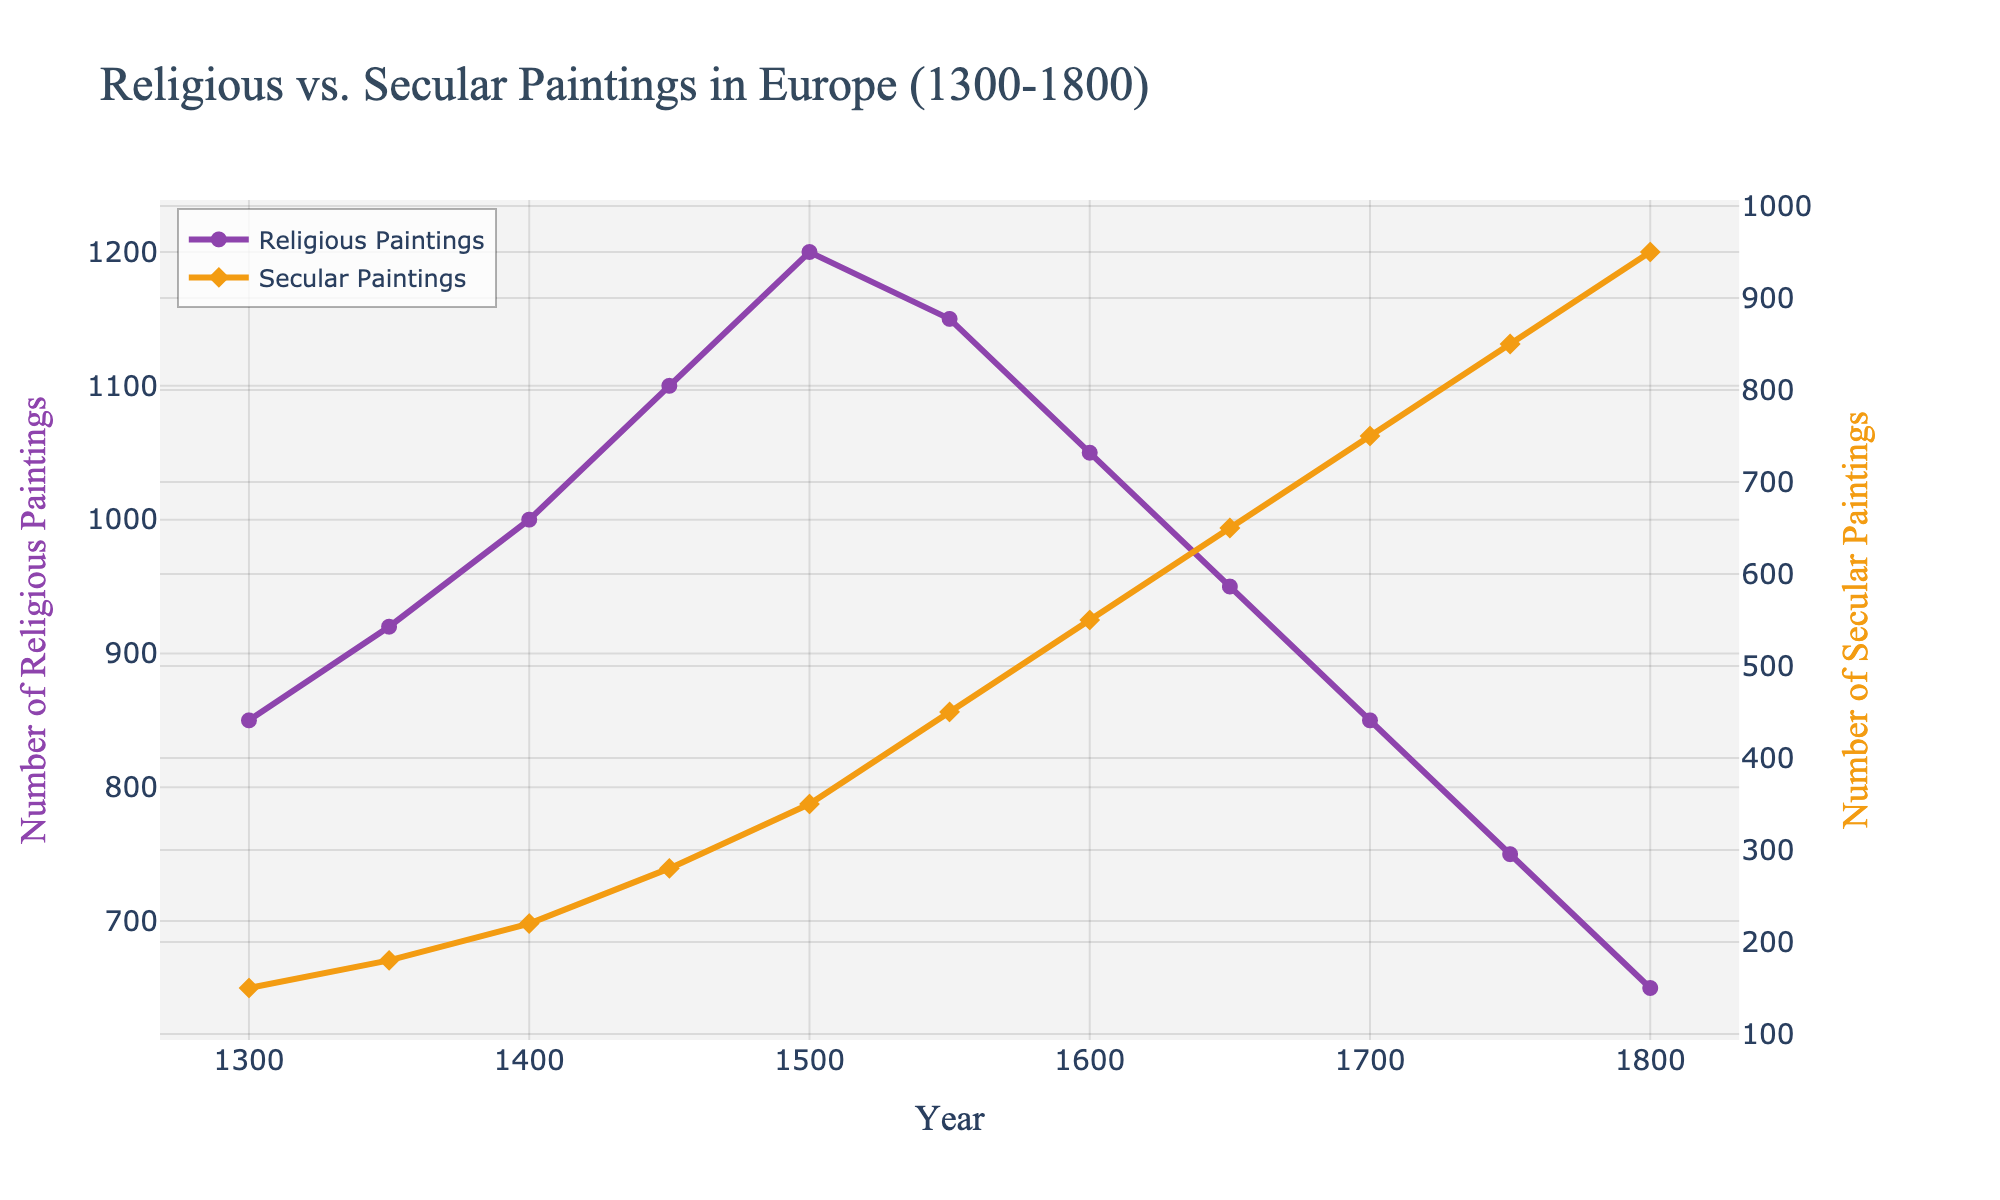Which year had the highest number of religious paintings? According to the figure, the highest peak for religious paintings is observed. By tracing this peak to the x-axis, it aligns with the year 1500.
Answer: 1500 In which year did secular paintings exceed religious paintings for the first time? By examining the crossover point of the two lines, we see that the secular paintings line becomes higher than the religious paintings line at the year 1650.
Answer: 1650 What is the total number of paintings (both religious and secular) produced in 1450? The number of religious paintings in 1450 is 1100, and the number of secular paintings is 280. Adding these gives us 1100 + 280.
Answer: 1380 How did the trend in religious paintings change from 1500 to 1800? The line for religious paintings shows a decline from 1500 onwards, decreasing steadily through 1800, suggesting a reduction in the production of religious-themed artwork over time.
Answer: Declining By how much did the number of secular paintings increase from 1300 to 1800? The number of secular paintings in 1300 was 150 and in 1800 it was 950. The increase can be calculated by subtracting the initial count from the final count: 950 - 150.
Answer: 800 What is the difference between the number of religious and secular paintings in 1700? In 1700, there are 850 religious paintings and 750 secular paintings. The difference is found by subtracting the smaller number from the larger: 850 - 750.
Answer: 100 Compare the trends of religious and secular paintings between 1600 and 1700. During this period, the number of religious paintings consistently decreases from 1050 to 850, while the number of secular paintings increases from 550 to 750, indicating an inverse relationship.
Answer: Declining vs Increasing What is the average number of secular paintings produced per year from 1300 to 1800? Summing the number of secular paintings over all the years and then dividing by the total number of years (950+850+750+...+150). This results in (150+180+220+280+350+450+550+650+750+850+950) / 11.
Answer: 561 During which century did secular paintings see the most significant growth? The steepest increase in secular paintings is observed between 1500 and 1600, where the figures rise rapidly from 350 to 550.
Answer: 16th century 